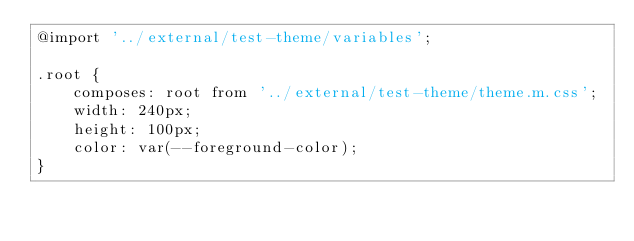<code> <loc_0><loc_0><loc_500><loc_500><_CSS_>@import '../external/test-theme/variables';

.root {
	composes: root from '../external/test-theme/theme.m.css';
	width: 240px;
	height: 100px;
	color: var(--foreground-color);
}
</code> 